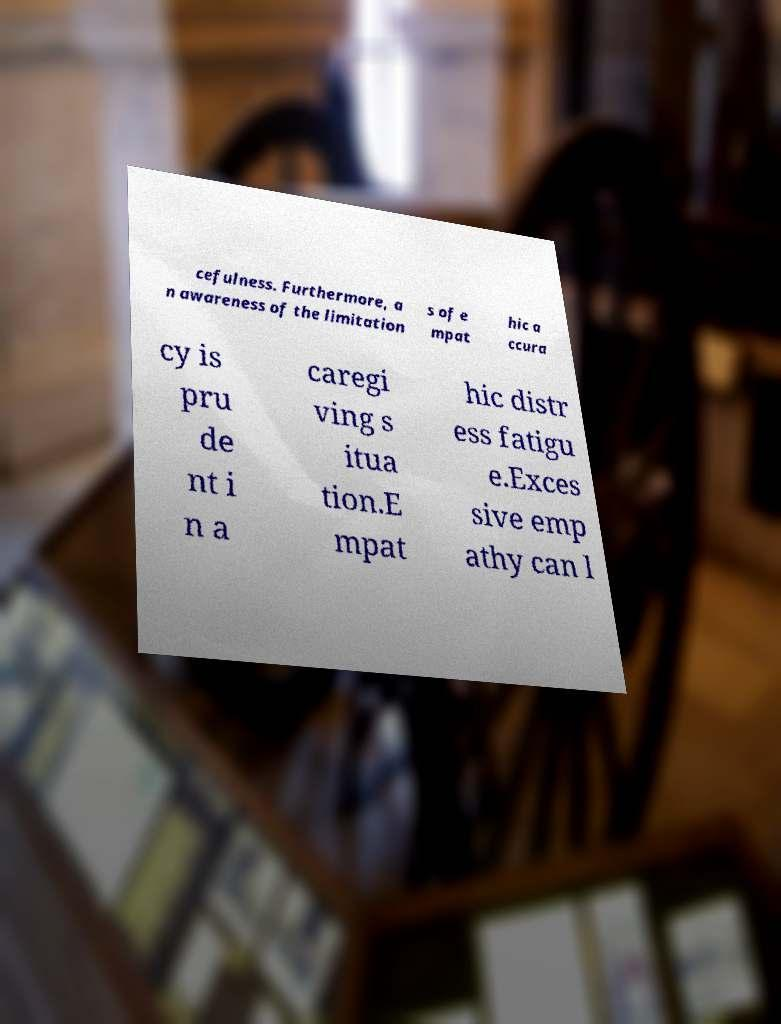There's text embedded in this image that I need extracted. Can you transcribe it verbatim? cefulness. Furthermore, a n awareness of the limitation s of e mpat hic a ccura cy is pru de nt i n a caregi ving s itua tion.E mpat hic distr ess fatigu e.Exces sive emp athy can l 